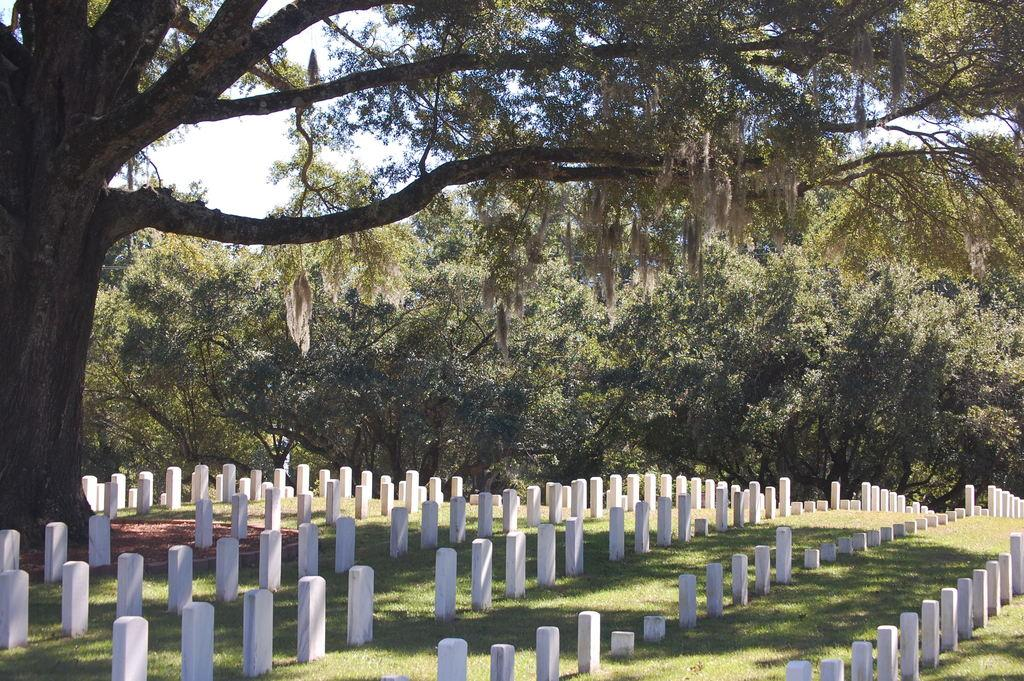What type of vegetation is present in the image? There are many trees in the image. What is covering the ground in the image? There is grass on the surface in the image. What type of objects can be seen on the ground in the image? There are stones in the image. What is visible at the top of the image? The sky is visible at the top of the image. What type of competition is taking place in the image? There is no competition present in the image. Can you tell me who is telling a joke in the image? There is no one telling a joke in the image. 